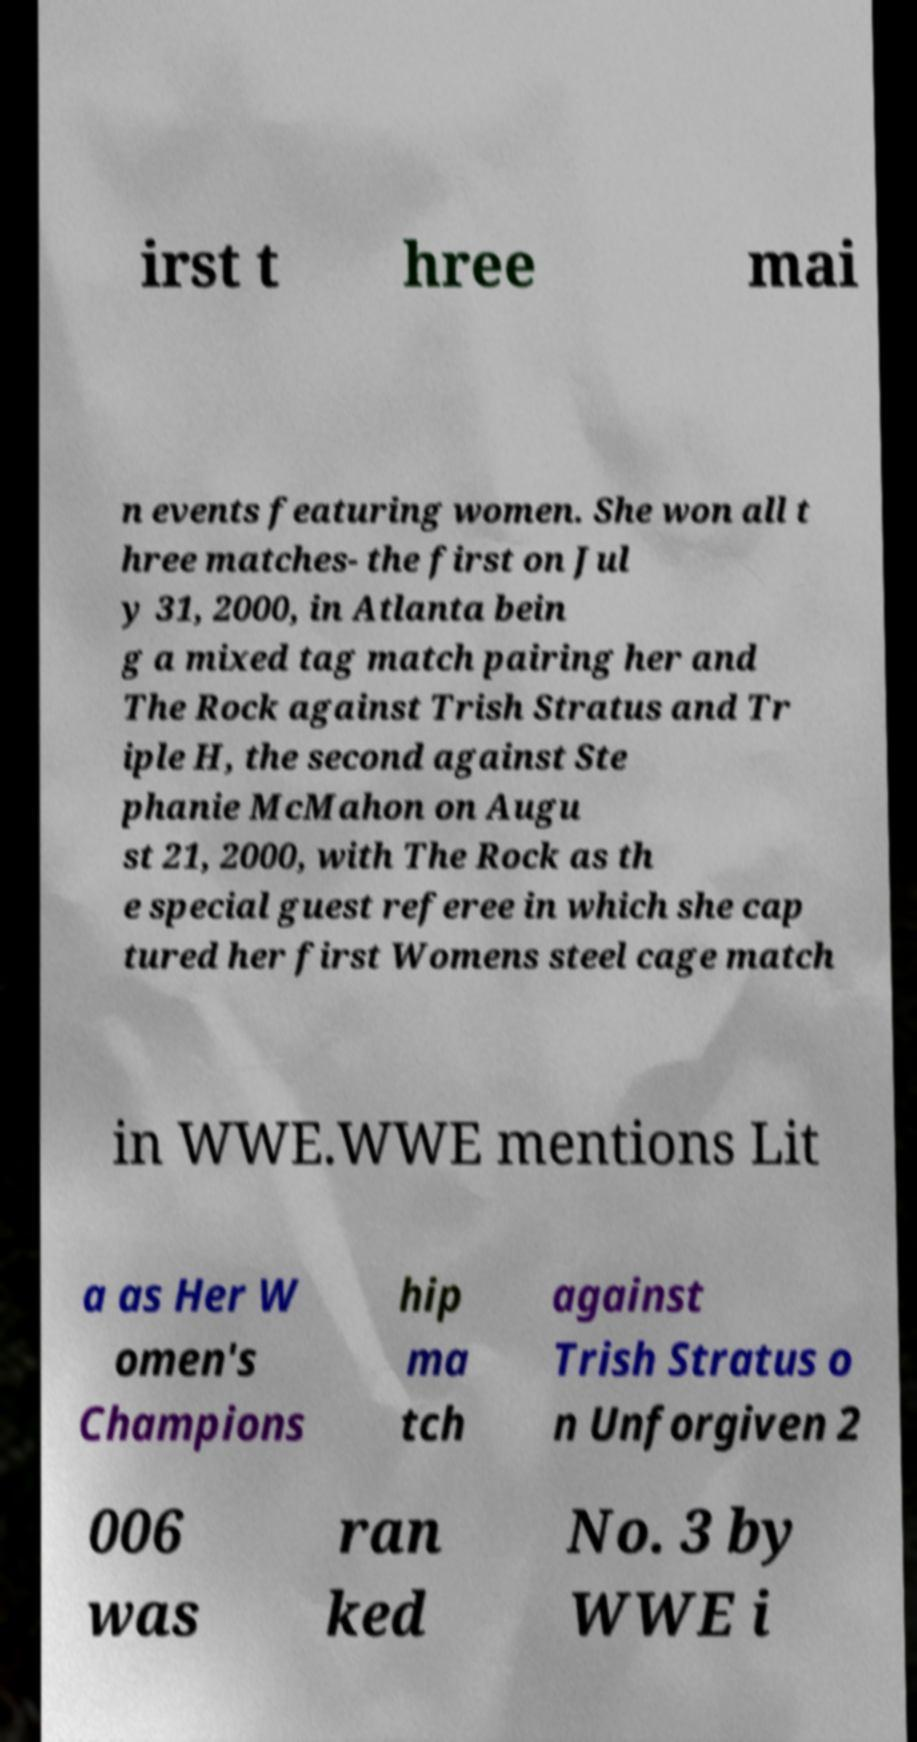Please identify and transcribe the text found in this image. irst t hree mai n events featuring women. She won all t hree matches- the first on Jul y 31, 2000, in Atlanta bein g a mixed tag match pairing her and The Rock against Trish Stratus and Tr iple H, the second against Ste phanie McMahon on Augu st 21, 2000, with The Rock as th e special guest referee in which she cap tured her first Womens steel cage match in WWE.WWE mentions Lit a as Her W omen's Champions hip ma tch against Trish Stratus o n Unforgiven 2 006 was ran ked No. 3 by WWE i 